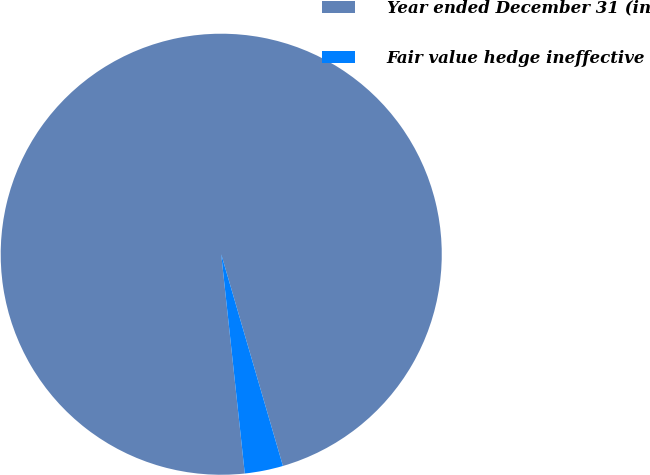Convert chart to OTSL. <chart><loc_0><loc_0><loc_500><loc_500><pie_chart><fcel>Year ended December 31 (in<fcel>Fair value hedge ineffective<nl><fcel>97.19%<fcel>2.81%<nl></chart> 